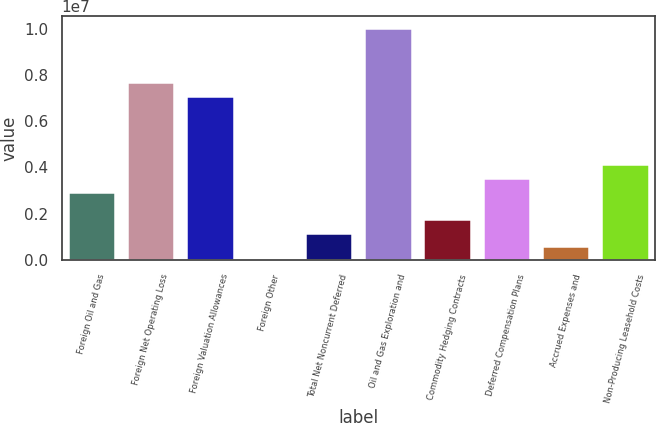Convert chart to OTSL. <chart><loc_0><loc_0><loc_500><loc_500><bar_chart><fcel>Foreign Oil and Gas<fcel>Foreign Net Operating Loss<fcel>Foreign Valuation Allowances<fcel>Foreign Other<fcel>Total Net Noncurrent Deferred<fcel>Oil and Gas Exploration and<fcel>Commodity Hedging Contracts<fcel>Deferred Compensation Plans<fcel>Accrued Expenses and<fcel>Non-Producing Leasehold Costs<nl><fcel>2.94999e+06<fcel>7.66926e+06<fcel>7.07935e+06<fcel>438<fcel>1.18026e+06<fcel>1.00289e+07<fcel>1.77017e+06<fcel>3.5399e+06<fcel>590348<fcel>4.1298e+06<nl></chart> 